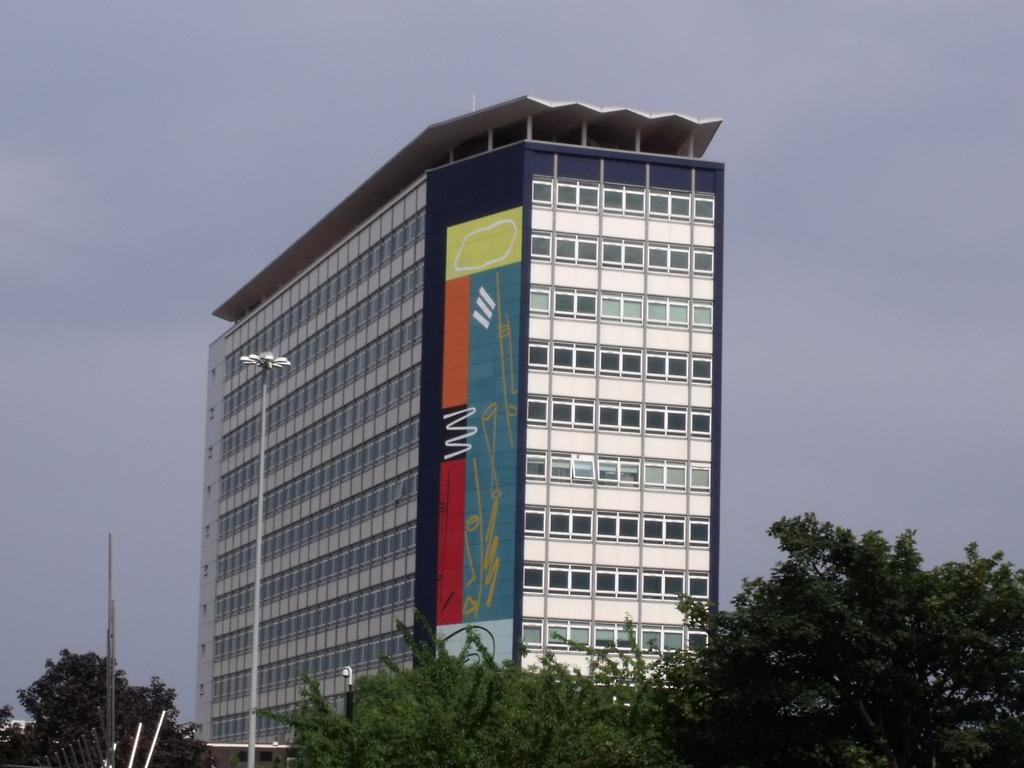Where was the picture taken? The picture was clicked outside. What can be seen in the foreground of the image? There are trees, metal rods, and a pole in the foreground of the image. What is visible in the background of the image? There is a building and the sky in the background of the image. What type of coal can be seen in the image? There is no coal present in the image. How many quince trees are visible in the image? There are no quince trees present in the image. 